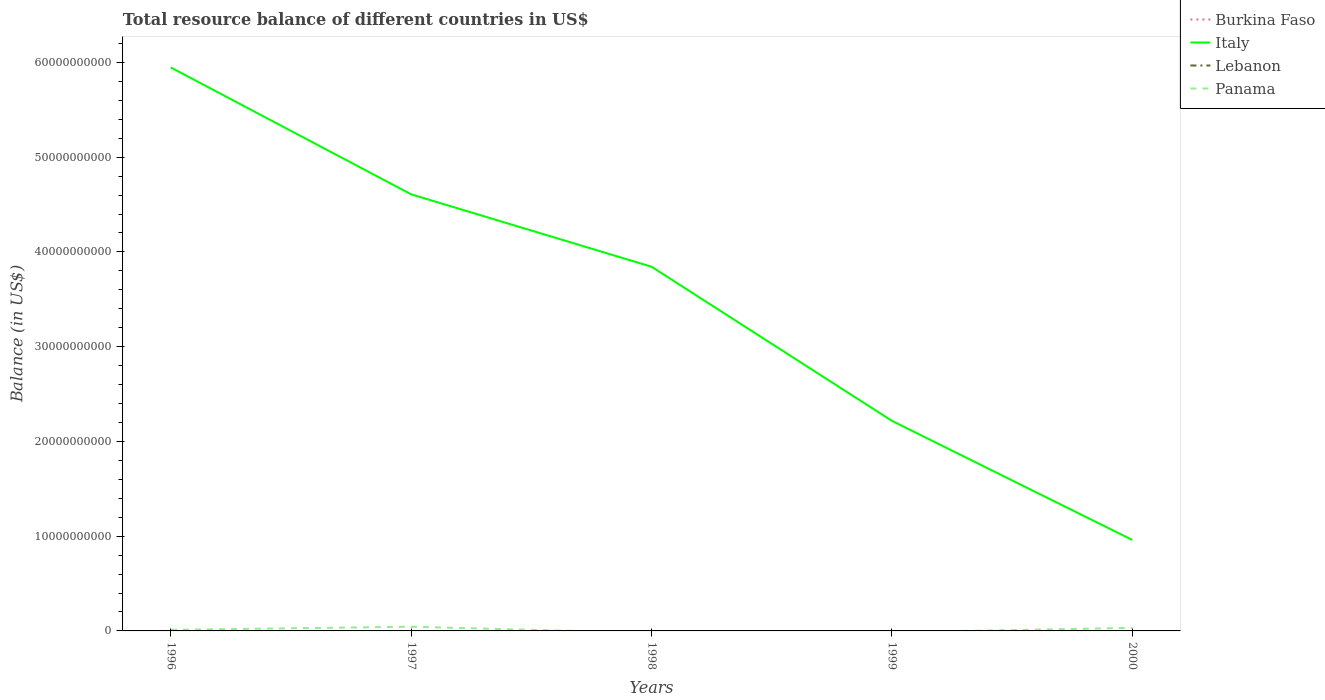How many different coloured lines are there?
Your answer should be very brief. 2. Is the number of lines equal to the number of legend labels?
Keep it short and to the point. No. What is the total total resource balance in Italy in the graph?
Your response must be concise. 3.73e+1. What is the difference between the highest and the second highest total resource balance in Panama?
Offer a terse response. 4.44e+08. Is the total resource balance in Italy strictly greater than the total resource balance in Lebanon over the years?
Provide a short and direct response. No. Are the values on the major ticks of Y-axis written in scientific E-notation?
Your response must be concise. No. Does the graph contain any zero values?
Your answer should be compact. Yes. Does the graph contain grids?
Your response must be concise. No. How many legend labels are there?
Ensure brevity in your answer.  4. How are the legend labels stacked?
Ensure brevity in your answer.  Vertical. What is the title of the graph?
Make the answer very short. Total resource balance of different countries in US$. What is the label or title of the Y-axis?
Your answer should be compact. Balance (in US$). What is the Balance (in US$) of Burkina Faso in 1996?
Give a very brief answer. 0. What is the Balance (in US$) in Italy in 1996?
Your response must be concise. 5.95e+1. What is the Balance (in US$) in Lebanon in 1996?
Provide a succinct answer. 0. What is the Balance (in US$) in Panama in 1996?
Make the answer very short. 1.17e+08. What is the Balance (in US$) in Burkina Faso in 1997?
Your response must be concise. 0. What is the Balance (in US$) in Italy in 1997?
Your response must be concise. 4.61e+1. What is the Balance (in US$) of Lebanon in 1997?
Your response must be concise. 0. What is the Balance (in US$) of Panama in 1997?
Ensure brevity in your answer.  4.44e+08. What is the Balance (in US$) in Italy in 1998?
Offer a very short reply. 3.84e+1. What is the Balance (in US$) in Italy in 1999?
Provide a short and direct response. 2.22e+1. What is the Balance (in US$) of Lebanon in 1999?
Your answer should be compact. 0. What is the Balance (in US$) of Panama in 1999?
Your answer should be very brief. 0. What is the Balance (in US$) of Burkina Faso in 2000?
Your answer should be very brief. 0. What is the Balance (in US$) in Italy in 2000?
Make the answer very short. 9.60e+09. What is the Balance (in US$) in Lebanon in 2000?
Provide a short and direct response. 0. What is the Balance (in US$) in Panama in 2000?
Keep it short and to the point. 3.20e+08. Across all years, what is the maximum Balance (in US$) of Italy?
Keep it short and to the point. 5.95e+1. Across all years, what is the maximum Balance (in US$) of Panama?
Offer a terse response. 4.44e+08. Across all years, what is the minimum Balance (in US$) of Italy?
Your answer should be very brief. 9.60e+09. Across all years, what is the minimum Balance (in US$) in Panama?
Offer a very short reply. 0. What is the total Balance (in US$) in Burkina Faso in the graph?
Ensure brevity in your answer.  0. What is the total Balance (in US$) in Italy in the graph?
Provide a short and direct response. 1.76e+11. What is the total Balance (in US$) in Panama in the graph?
Offer a terse response. 8.81e+08. What is the difference between the Balance (in US$) of Italy in 1996 and that in 1997?
Your answer should be very brief. 1.34e+1. What is the difference between the Balance (in US$) of Panama in 1996 and that in 1997?
Give a very brief answer. -3.27e+08. What is the difference between the Balance (in US$) of Italy in 1996 and that in 1998?
Offer a terse response. 2.10e+1. What is the difference between the Balance (in US$) in Italy in 1996 and that in 1999?
Provide a succinct answer. 3.73e+1. What is the difference between the Balance (in US$) of Italy in 1996 and that in 2000?
Offer a terse response. 4.99e+1. What is the difference between the Balance (in US$) in Panama in 1996 and that in 2000?
Ensure brevity in your answer.  -2.03e+08. What is the difference between the Balance (in US$) in Italy in 1997 and that in 1998?
Make the answer very short. 7.64e+09. What is the difference between the Balance (in US$) in Italy in 1997 and that in 1999?
Ensure brevity in your answer.  2.39e+1. What is the difference between the Balance (in US$) of Italy in 1997 and that in 2000?
Provide a succinct answer. 3.65e+1. What is the difference between the Balance (in US$) in Panama in 1997 and that in 2000?
Keep it short and to the point. 1.23e+08. What is the difference between the Balance (in US$) in Italy in 1998 and that in 1999?
Keep it short and to the point. 1.63e+1. What is the difference between the Balance (in US$) of Italy in 1998 and that in 2000?
Keep it short and to the point. 2.88e+1. What is the difference between the Balance (in US$) of Italy in 1999 and that in 2000?
Offer a terse response. 1.26e+1. What is the difference between the Balance (in US$) in Italy in 1996 and the Balance (in US$) in Panama in 1997?
Give a very brief answer. 5.90e+1. What is the difference between the Balance (in US$) of Italy in 1996 and the Balance (in US$) of Panama in 2000?
Provide a short and direct response. 5.91e+1. What is the difference between the Balance (in US$) in Italy in 1997 and the Balance (in US$) in Panama in 2000?
Provide a succinct answer. 4.58e+1. What is the difference between the Balance (in US$) of Italy in 1998 and the Balance (in US$) of Panama in 2000?
Keep it short and to the point. 3.81e+1. What is the difference between the Balance (in US$) of Italy in 1999 and the Balance (in US$) of Panama in 2000?
Keep it short and to the point. 2.19e+1. What is the average Balance (in US$) in Burkina Faso per year?
Give a very brief answer. 0. What is the average Balance (in US$) in Italy per year?
Offer a very short reply. 3.52e+1. What is the average Balance (in US$) in Lebanon per year?
Provide a succinct answer. 0. What is the average Balance (in US$) of Panama per year?
Keep it short and to the point. 1.76e+08. In the year 1996, what is the difference between the Balance (in US$) in Italy and Balance (in US$) in Panama?
Your response must be concise. 5.93e+1. In the year 1997, what is the difference between the Balance (in US$) of Italy and Balance (in US$) of Panama?
Provide a short and direct response. 4.56e+1. In the year 2000, what is the difference between the Balance (in US$) of Italy and Balance (in US$) of Panama?
Provide a succinct answer. 9.28e+09. What is the ratio of the Balance (in US$) of Italy in 1996 to that in 1997?
Provide a succinct answer. 1.29. What is the ratio of the Balance (in US$) of Panama in 1996 to that in 1997?
Ensure brevity in your answer.  0.26. What is the ratio of the Balance (in US$) of Italy in 1996 to that in 1998?
Provide a short and direct response. 1.55. What is the ratio of the Balance (in US$) of Italy in 1996 to that in 1999?
Provide a short and direct response. 2.68. What is the ratio of the Balance (in US$) of Italy in 1996 to that in 2000?
Make the answer very short. 6.19. What is the ratio of the Balance (in US$) in Panama in 1996 to that in 2000?
Your answer should be very brief. 0.36. What is the ratio of the Balance (in US$) of Italy in 1997 to that in 1998?
Your answer should be compact. 1.2. What is the ratio of the Balance (in US$) in Italy in 1997 to that in 1999?
Your response must be concise. 2.08. What is the ratio of the Balance (in US$) of Italy in 1997 to that in 2000?
Ensure brevity in your answer.  4.8. What is the ratio of the Balance (in US$) in Panama in 1997 to that in 2000?
Offer a very short reply. 1.39. What is the ratio of the Balance (in US$) of Italy in 1998 to that in 1999?
Give a very brief answer. 1.73. What is the ratio of the Balance (in US$) in Italy in 1998 to that in 2000?
Ensure brevity in your answer.  4. What is the ratio of the Balance (in US$) of Italy in 1999 to that in 2000?
Your answer should be very brief. 2.31. What is the difference between the highest and the second highest Balance (in US$) of Italy?
Provide a succinct answer. 1.34e+1. What is the difference between the highest and the second highest Balance (in US$) in Panama?
Offer a very short reply. 1.23e+08. What is the difference between the highest and the lowest Balance (in US$) of Italy?
Provide a succinct answer. 4.99e+1. What is the difference between the highest and the lowest Balance (in US$) of Panama?
Offer a terse response. 4.44e+08. 